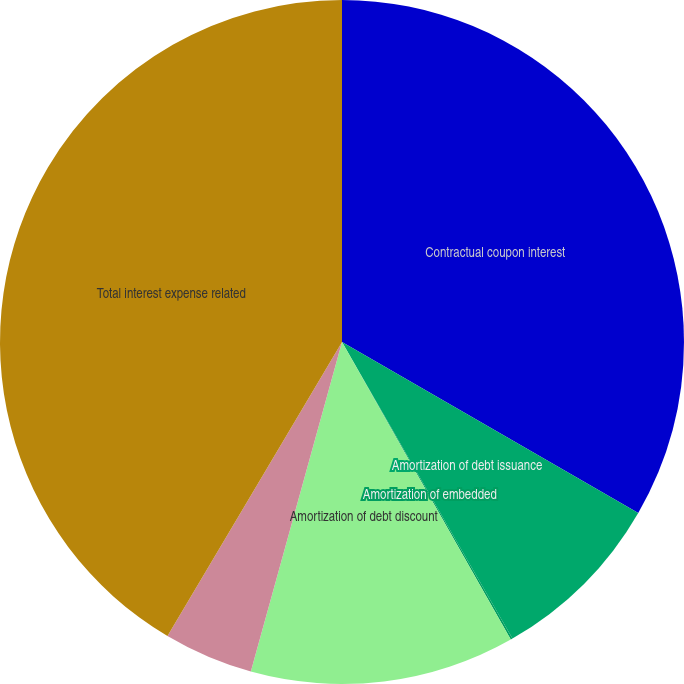<chart> <loc_0><loc_0><loc_500><loc_500><pie_chart><fcel>Contractual coupon interest<fcel>Amortization of debt issuance<fcel>Amortization of embedded<fcel>Amortization of debt discount<fcel>Fair value adjustment of<fcel>Total interest expense related<nl><fcel>33.33%<fcel>8.37%<fcel>0.09%<fcel>12.51%<fcel>4.23%<fcel>41.48%<nl></chart> 